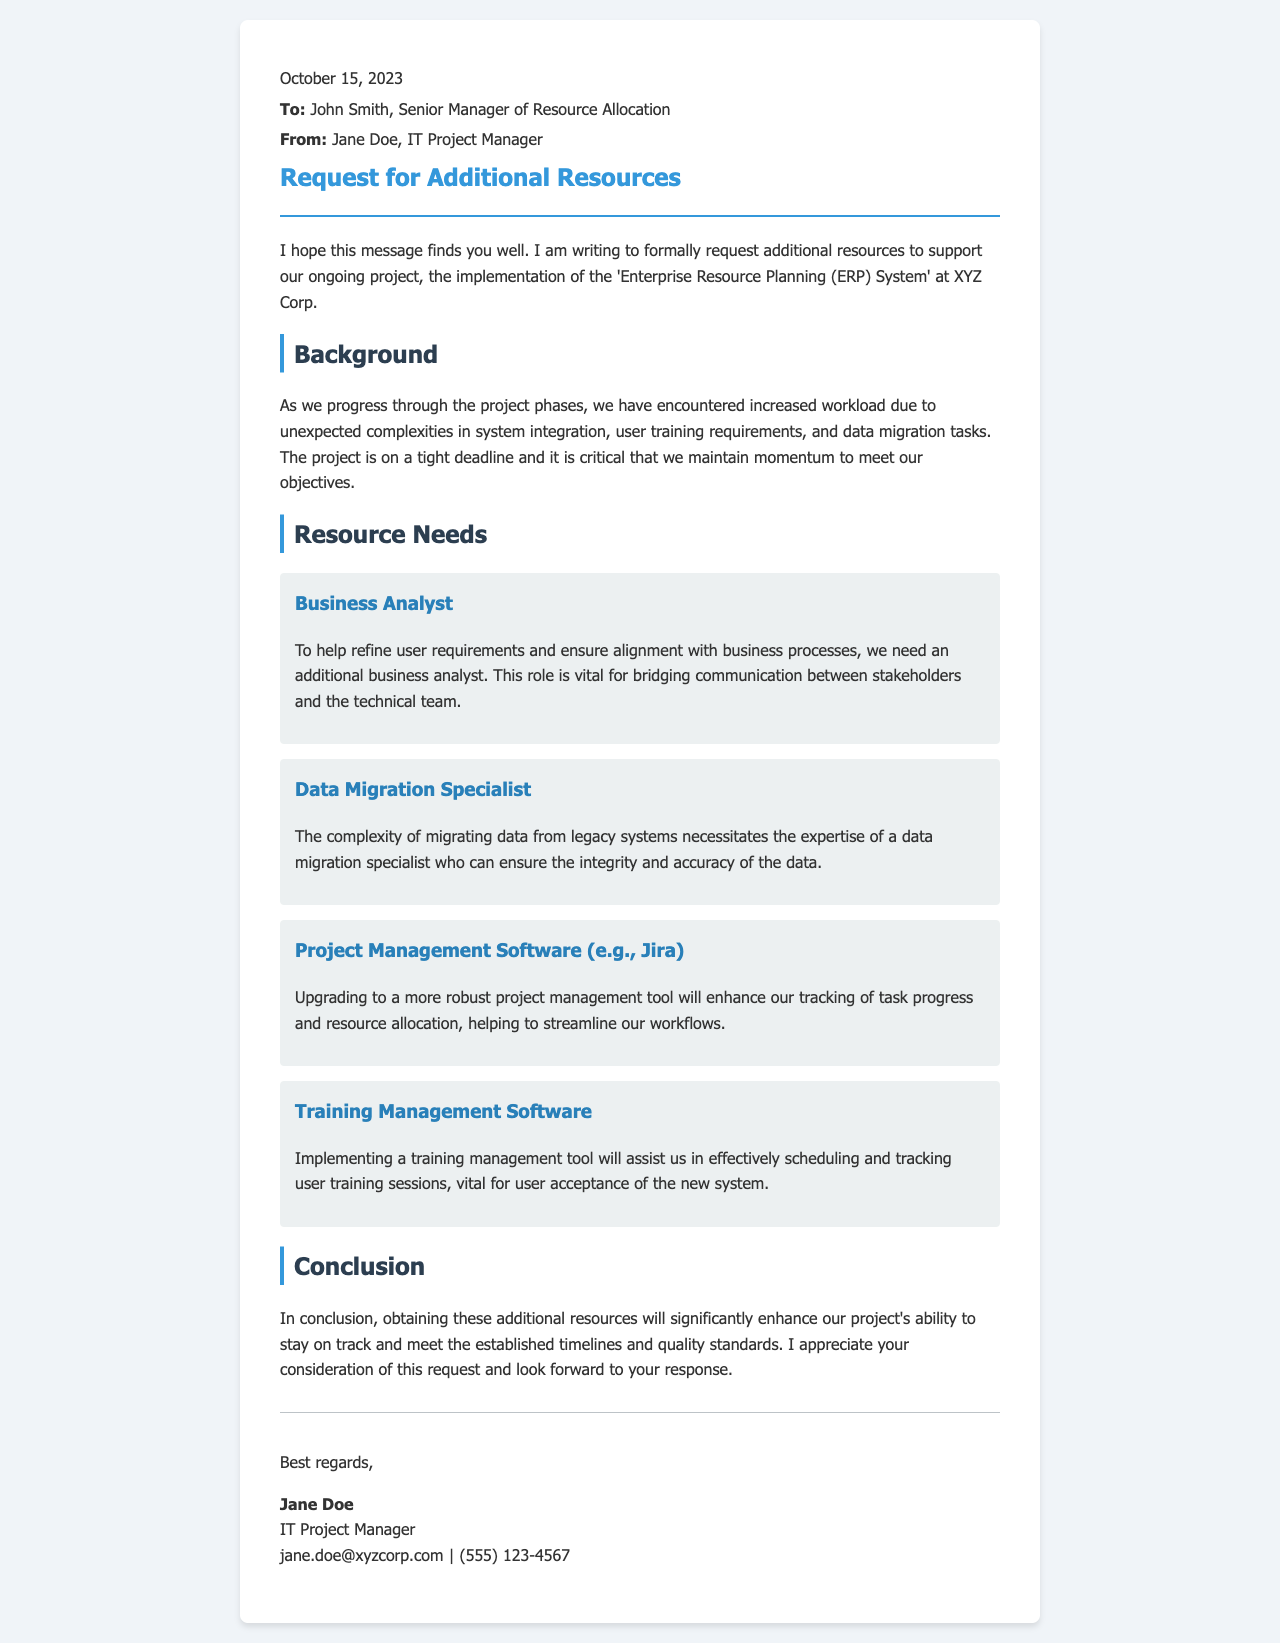what is the date of the letter? The date of the letter is clearly stated at the beginning, which is October 15, 2023.
Answer: October 15, 2023 who is the recipient of the letter? The letter is addressed to John Smith, who is the Senior Manager of Resource Allocation.
Answer: John Smith what is the project name mentioned in the document? The project being discussed in the letter is the implementation of the 'Enterprise Resource Planning (ERP) System'.
Answer: Enterprise Resource Planning (ERP) System how many resource needs are listed in the document? The document lists a total of four specific resource needs to support the project tasks.
Answer: Four which tool is recommended for project management? The letter suggests upgrading to a more robust project management tool, specifically mentioning Jira.
Answer: Jira what is the purpose of requesting a Data Migration Specialist? The need for a Data Migration Specialist arises from the complexity of migrating data and ensuring integrity and accuracy.
Answer: Ensuring integrity and accuracy which role is highlighted as essential for communication between stakeholders? The document emphasizes the importance of having an additional Business Analyst for bridging communication.
Answer: Business Analyst what type of software is mentioned for user training management? The letter mentions the need for Training Management Software to assist in scheduling and tracking user training sessions.
Answer: Training Management Software 